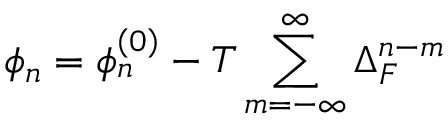<formula> <loc_0><loc_0><loc_500><loc_500>\phi _ { n } = \phi _ { n } ^ { \left ( 0 \right ) } - T \sum _ { m = - \infty } ^ { \infty } \Delta _ { F } ^ { n - m }</formula> 